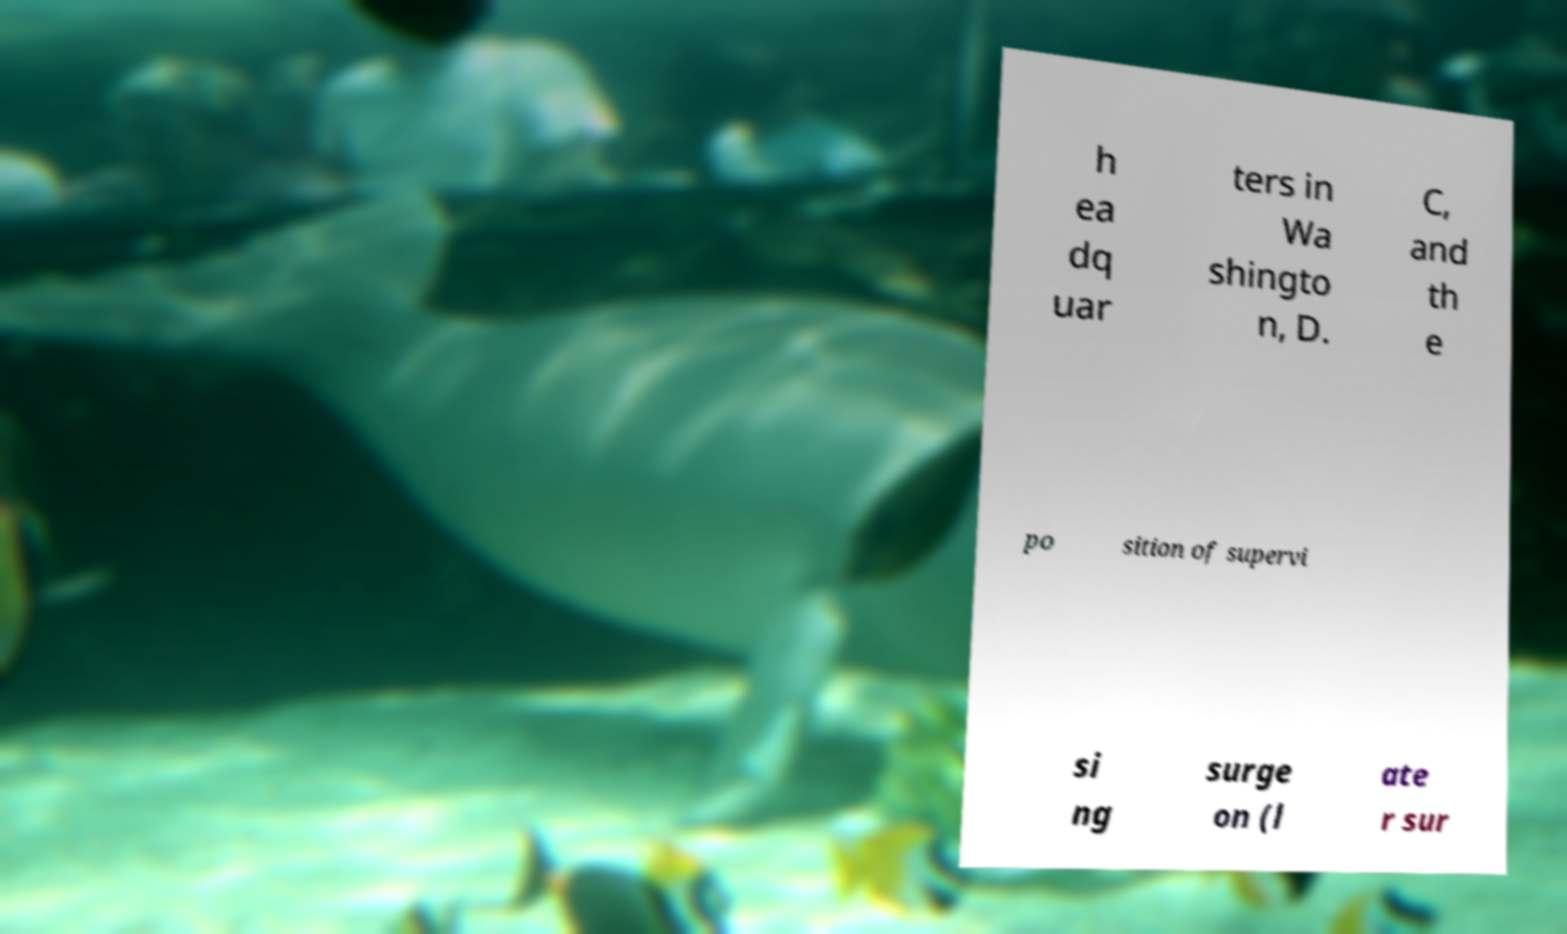There's text embedded in this image that I need extracted. Can you transcribe it verbatim? h ea dq uar ters in Wa shingto n, D. C, and th e po sition of supervi si ng surge on (l ate r sur 